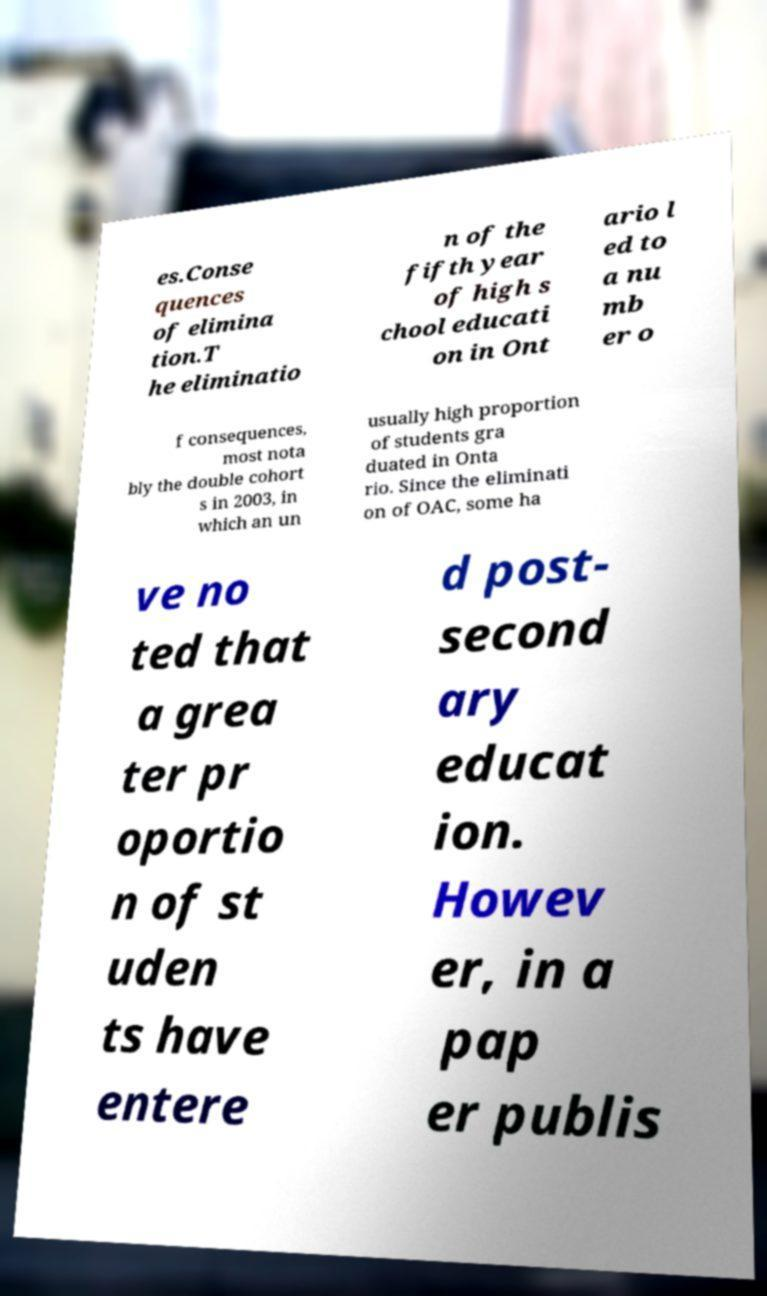I need the written content from this picture converted into text. Can you do that? es.Conse quences of elimina tion.T he eliminatio n of the fifth year of high s chool educati on in Ont ario l ed to a nu mb er o f consequences, most nota bly the double cohort s in 2003, in which an un usually high proportion of students gra duated in Onta rio. Since the eliminati on of OAC, some ha ve no ted that a grea ter pr oportio n of st uden ts have entere d post- second ary educat ion. Howev er, in a pap er publis 